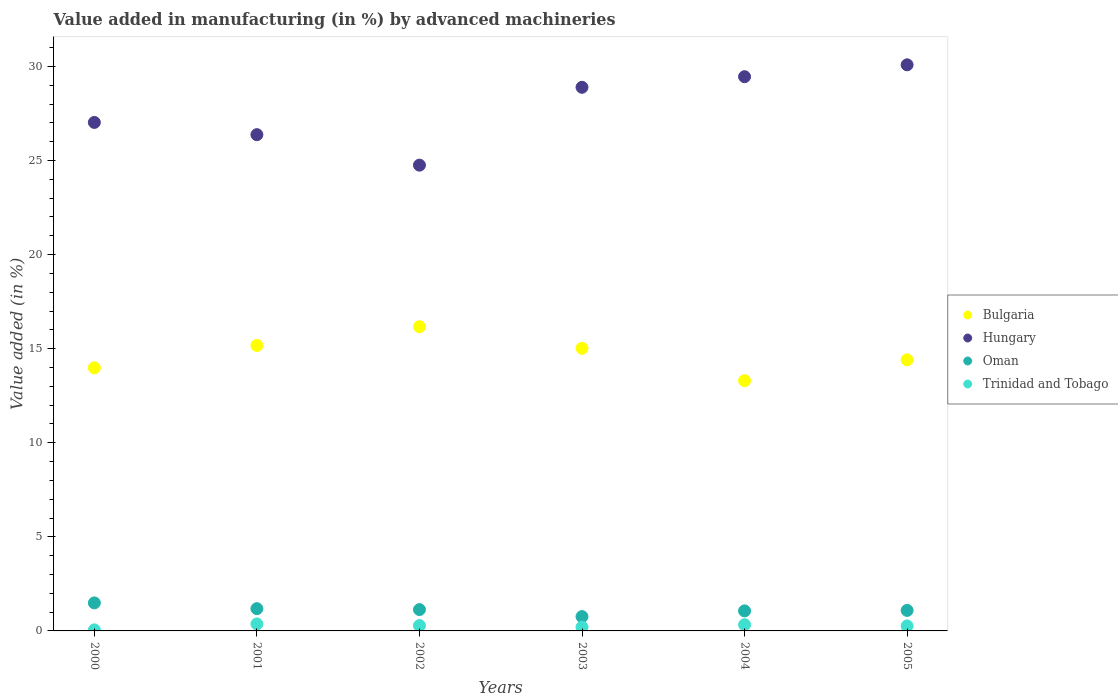Is the number of dotlines equal to the number of legend labels?
Offer a very short reply. Yes. What is the percentage of value added in manufacturing by advanced machineries in Hungary in 2002?
Keep it short and to the point. 24.76. Across all years, what is the maximum percentage of value added in manufacturing by advanced machineries in Hungary?
Offer a terse response. 30.09. Across all years, what is the minimum percentage of value added in manufacturing by advanced machineries in Bulgaria?
Offer a terse response. 13.3. In which year was the percentage of value added in manufacturing by advanced machineries in Bulgaria maximum?
Give a very brief answer. 2002. What is the total percentage of value added in manufacturing by advanced machineries in Bulgaria in the graph?
Keep it short and to the point. 88.06. What is the difference between the percentage of value added in manufacturing by advanced machineries in Oman in 2000 and that in 2005?
Make the answer very short. 0.4. What is the difference between the percentage of value added in manufacturing by advanced machineries in Bulgaria in 2003 and the percentage of value added in manufacturing by advanced machineries in Trinidad and Tobago in 2005?
Give a very brief answer. 14.76. What is the average percentage of value added in manufacturing by advanced machineries in Oman per year?
Your response must be concise. 1.12. In the year 2003, what is the difference between the percentage of value added in manufacturing by advanced machineries in Hungary and percentage of value added in manufacturing by advanced machineries in Oman?
Give a very brief answer. 28.13. In how many years, is the percentage of value added in manufacturing by advanced machineries in Hungary greater than 20 %?
Offer a terse response. 6. What is the ratio of the percentage of value added in manufacturing by advanced machineries in Oman in 2001 to that in 2003?
Give a very brief answer. 1.55. What is the difference between the highest and the second highest percentage of value added in manufacturing by advanced machineries in Hungary?
Your response must be concise. 0.63. What is the difference between the highest and the lowest percentage of value added in manufacturing by advanced machineries in Trinidad and Tobago?
Your response must be concise. 0.31. In how many years, is the percentage of value added in manufacturing by advanced machineries in Oman greater than the average percentage of value added in manufacturing by advanced machineries in Oman taken over all years?
Offer a very short reply. 3. Is the sum of the percentage of value added in manufacturing by advanced machineries in Hungary in 2000 and 2003 greater than the maximum percentage of value added in manufacturing by advanced machineries in Bulgaria across all years?
Offer a very short reply. Yes. Is it the case that in every year, the sum of the percentage of value added in manufacturing by advanced machineries in Bulgaria and percentage of value added in manufacturing by advanced machineries in Oman  is greater than the sum of percentage of value added in manufacturing by advanced machineries in Hungary and percentage of value added in manufacturing by advanced machineries in Trinidad and Tobago?
Make the answer very short. Yes. Does the percentage of value added in manufacturing by advanced machineries in Trinidad and Tobago monotonically increase over the years?
Ensure brevity in your answer.  No. How many dotlines are there?
Your response must be concise. 4. How many years are there in the graph?
Your answer should be very brief. 6. Are the values on the major ticks of Y-axis written in scientific E-notation?
Your response must be concise. No. Does the graph contain any zero values?
Provide a short and direct response. No. Where does the legend appear in the graph?
Keep it short and to the point. Center right. How many legend labels are there?
Provide a short and direct response. 4. How are the legend labels stacked?
Offer a terse response. Vertical. What is the title of the graph?
Provide a short and direct response. Value added in manufacturing (in %) by advanced machineries. Does "Qatar" appear as one of the legend labels in the graph?
Offer a very short reply. No. What is the label or title of the Y-axis?
Provide a succinct answer. Value added (in %). What is the Value added (in %) in Bulgaria in 2000?
Keep it short and to the point. 13.99. What is the Value added (in %) in Hungary in 2000?
Your answer should be compact. 27.03. What is the Value added (in %) of Oman in 2000?
Ensure brevity in your answer.  1.49. What is the Value added (in %) in Trinidad and Tobago in 2000?
Your response must be concise. 0.06. What is the Value added (in %) in Bulgaria in 2001?
Offer a terse response. 15.17. What is the Value added (in %) of Hungary in 2001?
Your response must be concise. 26.38. What is the Value added (in %) in Oman in 2001?
Your response must be concise. 1.18. What is the Value added (in %) in Trinidad and Tobago in 2001?
Ensure brevity in your answer.  0.37. What is the Value added (in %) in Bulgaria in 2002?
Offer a terse response. 16.17. What is the Value added (in %) of Hungary in 2002?
Your response must be concise. 24.76. What is the Value added (in %) of Oman in 2002?
Provide a short and direct response. 1.13. What is the Value added (in %) of Trinidad and Tobago in 2002?
Ensure brevity in your answer.  0.28. What is the Value added (in %) in Bulgaria in 2003?
Provide a succinct answer. 15.02. What is the Value added (in %) of Hungary in 2003?
Your answer should be very brief. 28.89. What is the Value added (in %) of Oman in 2003?
Make the answer very short. 0.76. What is the Value added (in %) in Trinidad and Tobago in 2003?
Provide a short and direct response. 0.2. What is the Value added (in %) in Bulgaria in 2004?
Make the answer very short. 13.3. What is the Value added (in %) in Hungary in 2004?
Make the answer very short. 29.46. What is the Value added (in %) in Oman in 2004?
Give a very brief answer. 1.07. What is the Value added (in %) in Trinidad and Tobago in 2004?
Make the answer very short. 0.33. What is the Value added (in %) in Bulgaria in 2005?
Ensure brevity in your answer.  14.41. What is the Value added (in %) in Hungary in 2005?
Offer a very short reply. 30.09. What is the Value added (in %) of Oman in 2005?
Offer a terse response. 1.09. What is the Value added (in %) of Trinidad and Tobago in 2005?
Offer a terse response. 0.27. Across all years, what is the maximum Value added (in %) of Bulgaria?
Make the answer very short. 16.17. Across all years, what is the maximum Value added (in %) of Hungary?
Provide a succinct answer. 30.09. Across all years, what is the maximum Value added (in %) of Oman?
Offer a very short reply. 1.49. Across all years, what is the maximum Value added (in %) of Trinidad and Tobago?
Your answer should be compact. 0.37. Across all years, what is the minimum Value added (in %) in Bulgaria?
Make the answer very short. 13.3. Across all years, what is the minimum Value added (in %) in Hungary?
Your answer should be compact. 24.76. Across all years, what is the minimum Value added (in %) in Oman?
Offer a very short reply. 0.76. Across all years, what is the minimum Value added (in %) in Trinidad and Tobago?
Give a very brief answer. 0.06. What is the total Value added (in %) of Bulgaria in the graph?
Make the answer very short. 88.06. What is the total Value added (in %) of Hungary in the graph?
Provide a succinct answer. 166.6. What is the total Value added (in %) in Oman in the graph?
Give a very brief answer. 6.72. What is the total Value added (in %) of Trinidad and Tobago in the graph?
Your answer should be compact. 1.51. What is the difference between the Value added (in %) in Bulgaria in 2000 and that in 2001?
Your answer should be compact. -1.19. What is the difference between the Value added (in %) in Hungary in 2000 and that in 2001?
Provide a short and direct response. 0.65. What is the difference between the Value added (in %) of Oman in 2000 and that in 2001?
Offer a very short reply. 0.31. What is the difference between the Value added (in %) in Trinidad and Tobago in 2000 and that in 2001?
Offer a very short reply. -0.31. What is the difference between the Value added (in %) of Bulgaria in 2000 and that in 2002?
Make the answer very short. -2.18. What is the difference between the Value added (in %) of Hungary in 2000 and that in 2002?
Give a very brief answer. 2.27. What is the difference between the Value added (in %) in Oman in 2000 and that in 2002?
Give a very brief answer. 0.36. What is the difference between the Value added (in %) in Trinidad and Tobago in 2000 and that in 2002?
Give a very brief answer. -0.23. What is the difference between the Value added (in %) of Bulgaria in 2000 and that in 2003?
Keep it short and to the point. -1.04. What is the difference between the Value added (in %) in Hungary in 2000 and that in 2003?
Offer a very short reply. -1.87. What is the difference between the Value added (in %) in Oman in 2000 and that in 2003?
Make the answer very short. 0.73. What is the difference between the Value added (in %) of Trinidad and Tobago in 2000 and that in 2003?
Your answer should be very brief. -0.15. What is the difference between the Value added (in %) of Bulgaria in 2000 and that in 2004?
Make the answer very short. 0.68. What is the difference between the Value added (in %) of Hungary in 2000 and that in 2004?
Your answer should be compact. -2.43. What is the difference between the Value added (in %) of Oman in 2000 and that in 2004?
Keep it short and to the point. 0.42. What is the difference between the Value added (in %) in Trinidad and Tobago in 2000 and that in 2004?
Give a very brief answer. -0.27. What is the difference between the Value added (in %) of Bulgaria in 2000 and that in 2005?
Provide a short and direct response. -0.42. What is the difference between the Value added (in %) of Hungary in 2000 and that in 2005?
Provide a succinct answer. -3.06. What is the difference between the Value added (in %) in Oman in 2000 and that in 2005?
Keep it short and to the point. 0.4. What is the difference between the Value added (in %) in Trinidad and Tobago in 2000 and that in 2005?
Ensure brevity in your answer.  -0.21. What is the difference between the Value added (in %) in Bulgaria in 2001 and that in 2002?
Keep it short and to the point. -1. What is the difference between the Value added (in %) in Hungary in 2001 and that in 2002?
Keep it short and to the point. 1.62. What is the difference between the Value added (in %) in Trinidad and Tobago in 2001 and that in 2002?
Your answer should be compact. 0.09. What is the difference between the Value added (in %) in Bulgaria in 2001 and that in 2003?
Ensure brevity in your answer.  0.15. What is the difference between the Value added (in %) in Hungary in 2001 and that in 2003?
Offer a terse response. -2.52. What is the difference between the Value added (in %) of Oman in 2001 and that in 2003?
Provide a short and direct response. 0.42. What is the difference between the Value added (in %) of Trinidad and Tobago in 2001 and that in 2003?
Offer a terse response. 0.17. What is the difference between the Value added (in %) in Bulgaria in 2001 and that in 2004?
Ensure brevity in your answer.  1.87. What is the difference between the Value added (in %) of Hungary in 2001 and that in 2004?
Offer a very short reply. -3.08. What is the difference between the Value added (in %) of Oman in 2001 and that in 2004?
Ensure brevity in your answer.  0.12. What is the difference between the Value added (in %) of Trinidad and Tobago in 2001 and that in 2004?
Give a very brief answer. 0.04. What is the difference between the Value added (in %) of Bulgaria in 2001 and that in 2005?
Give a very brief answer. 0.76. What is the difference between the Value added (in %) in Hungary in 2001 and that in 2005?
Provide a succinct answer. -3.71. What is the difference between the Value added (in %) of Oman in 2001 and that in 2005?
Your answer should be compact. 0.09. What is the difference between the Value added (in %) of Trinidad and Tobago in 2001 and that in 2005?
Provide a short and direct response. 0.1. What is the difference between the Value added (in %) in Bulgaria in 2002 and that in 2003?
Your response must be concise. 1.15. What is the difference between the Value added (in %) in Hungary in 2002 and that in 2003?
Your answer should be compact. -4.14. What is the difference between the Value added (in %) in Oman in 2002 and that in 2003?
Offer a very short reply. 0.37. What is the difference between the Value added (in %) in Trinidad and Tobago in 2002 and that in 2003?
Your answer should be very brief. 0.08. What is the difference between the Value added (in %) in Bulgaria in 2002 and that in 2004?
Offer a very short reply. 2.87. What is the difference between the Value added (in %) in Hungary in 2002 and that in 2004?
Provide a short and direct response. -4.7. What is the difference between the Value added (in %) of Oman in 2002 and that in 2004?
Your answer should be compact. 0.07. What is the difference between the Value added (in %) of Trinidad and Tobago in 2002 and that in 2004?
Your answer should be compact. -0.05. What is the difference between the Value added (in %) of Bulgaria in 2002 and that in 2005?
Provide a short and direct response. 1.76. What is the difference between the Value added (in %) of Hungary in 2002 and that in 2005?
Make the answer very short. -5.33. What is the difference between the Value added (in %) in Oman in 2002 and that in 2005?
Offer a very short reply. 0.04. What is the difference between the Value added (in %) of Trinidad and Tobago in 2002 and that in 2005?
Provide a short and direct response. 0.02. What is the difference between the Value added (in %) in Bulgaria in 2003 and that in 2004?
Offer a terse response. 1.72. What is the difference between the Value added (in %) of Hungary in 2003 and that in 2004?
Ensure brevity in your answer.  -0.56. What is the difference between the Value added (in %) in Oman in 2003 and that in 2004?
Ensure brevity in your answer.  -0.3. What is the difference between the Value added (in %) in Trinidad and Tobago in 2003 and that in 2004?
Give a very brief answer. -0.13. What is the difference between the Value added (in %) of Bulgaria in 2003 and that in 2005?
Offer a terse response. 0.61. What is the difference between the Value added (in %) in Hungary in 2003 and that in 2005?
Your response must be concise. -1.19. What is the difference between the Value added (in %) in Oman in 2003 and that in 2005?
Your response must be concise. -0.33. What is the difference between the Value added (in %) of Trinidad and Tobago in 2003 and that in 2005?
Offer a terse response. -0.06. What is the difference between the Value added (in %) of Bulgaria in 2004 and that in 2005?
Offer a very short reply. -1.11. What is the difference between the Value added (in %) in Hungary in 2004 and that in 2005?
Your response must be concise. -0.63. What is the difference between the Value added (in %) in Oman in 2004 and that in 2005?
Provide a short and direct response. -0.03. What is the difference between the Value added (in %) in Trinidad and Tobago in 2004 and that in 2005?
Make the answer very short. 0.06. What is the difference between the Value added (in %) of Bulgaria in 2000 and the Value added (in %) of Hungary in 2001?
Provide a short and direct response. -12.39. What is the difference between the Value added (in %) in Bulgaria in 2000 and the Value added (in %) in Oman in 2001?
Your response must be concise. 12.8. What is the difference between the Value added (in %) of Bulgaria in 2000 and the Value added (in %) of Trinidad and Tobago in 2001?
Your answer should be very brief. 13.61. What is the difference between the Value added (in %) in Hungary in 2000 and the Value added (in %) in Oman in 2001?
Your answer should be compact. 25.84. What is the difference between the Value added (in %) in Hungary in 2000 and the Value added (in %) in Trinidad and Tobago in 2001?
Offer a very short reply. 26.66. What is the difference between the Value added (in %) of Oman in 2000 and the Value added (in %) of Trinidad and Tobago in 2001?
Provide a succinct answer. 1.12. What is the difference between the Value added (in %) in Bulgaria in 2000 and the Value added (in %) in Hungary in 2002?
Keep it short and to the point. -10.77. What is the difference between the Value added (in %) of Bulgaria in 2000 and the Value added (in %) of Oman in 2002?
Give a very brief answer. 12.85. What is the difference between the Value added (in %) in Bulgaria in 2000 and the Value added (in %) in Trinidad and Tobago in 2002?
Keep it short and to the point. 13.7. What is the difference between the Value added (in %) of Hungary in 2000 and the Value added (in %) of Oman in 2002?
Provide a short and direct response. 25.89. What is the difference between the Value added (in %) in Hungary in 2000 and the Value added (in %) in Trinidad and Tobago in 2002?
Offer a very short reply. 26.74. What is the difference between the Value added (in %) of Oman in 2000 and the Value added (in %) of Trinidad and Tobago in 2002?
Your answer should be compact. 1.21. What is the difference between the Value added (in %) of Bulgaria in 2000 and the Value added (in %) of Hungary in 2003?
Make the answer very short. -14.91. What is the difference between the Value added (in %) of Bulgaria in 2000 and the Value added (in %) of Oman in 2003?
Your response must be concise. 13.22. What is the difference between the Value added (in %) of Bulgaria in 2000 and the Value added (in %) of Trinidad and Tobago in 2003?
Ensure brevity in your answer.  13.78. What is the difference between the Value added (in %) of Hungary in 2000 and the Value added (in %) of Oman in 2003?
Make the answer very short. 26.26. What is the difference between the Value added (in %) of Hungary in 2000 and the Value added (in %) of Trinidad and Tobago in 2003?
Your answer should be compact. 26.82. What is the difference between the Value added (in %) in Oman in 2000 and the Value added (in %) in Trinidad and Tobago in 2003?
Keep it short and to the point. 1.29. What is the difference between the Value added (in %) of Bulgaria in 2000 and the Value added (in %) of Hungary in 2004?
Keep it short and to the point. -15.47. What is the difference between the Value added (in %) of Bulgaria in 2000 and the Value added (in %) of Oman in 2004?
Keep it short and to the point. 12.92. What is the difference between the Value added (in %) in Bulgaria in 2000 and the Value added (in %) in Trinidad and Tobago in 2004?
Your response must be concise. 13.65. What is the difference between the Value added (in %) of Hungary in 2000 and the Value added (in %) of Oman in 2004?
Make the answer very short. 25.96. What is the difference between the Value added (in %) in Hungary in 2000 and the Value added (in %) in Trinidad and Tobago in 2004?
Provide a succinct answer. 26.7. What is the difference between the Value added (in %) of Oman in 2000 and the Value added (in %) of Trinidad and Tobago in 2004?
Your answer should be very brief. 1.16. What is the difference between the Value added (in %) in Bulgaria in 2000 and the Value added (in %) in Hungary in 2005?
Offer a very short reply. -16.1. What is the difference between the Value added (in %) in Bulgaria in 2000 and the Value added (in %) in Oman in 2005?
Provide a succinct answer. 12.89. What is the difference between the Value added (in %) in Bulgaria in 2000 and the Value added (in %) in Trinidad and Tobago in 2005?
Provide a short and direct response. 13.72. What is the difference between the Value added (in %) of Hungary in 2000 and the Value added (in %) of Oman in 2005?
Make the answer very short. 25.94. What is the difference between the Value added (in %) of Hungary in 2000 and the Value added (in %) of Trinidad and Tobago in 2005?
Give a very brief answer. 26.76. What is the difference between the Value added (in %) in Oman in 2000 and the Value added (in %) in Trinidad and Tobago in 2005?
Your answer should be compact. 1.22. What is the difference between the Value added (in %) of Bulgaria in 2001 and the Value added (in %) of Hungary in 2002?
Your response must be concise. -9.58. What is the difference between the Value added (in %) of Bulgaria in 2001 and the Value added (in %) of Oman in 2002?
Offer a very short reply. 14.04. What is the difference between the Value added (in %) of Bulgaria in 2001 and the Value added (in %) of Trinidad and Tobago in 2002?
Your answer should be compact. 14.89. What is the difference between the Value added (in %) in Hungary in 2001 and the Value added (in %) in Oman in 2002?
Your answer should be very brief. 25.24. What is the difference between the Value added (in %) of Hungary in 2001 and the Value added (in %) of Trinidad and Tobago in 2002?
Offer a terse response. 26.09. What is the difference between the Value added (in %) in Oman in 2001 and the Value added (in %) in Trinidad and Tobago in 2002?
Provide a short and direct response. 0.9. What is the difference between the Value added (in %) in Bulgaria in 2001 and the Value added (in %) in Hungary in 2003?
Keep it short and to the point. -13.72. What is the difference between the Value added (in %) in Bulgaria in 2001 and the Value added (in %) in Oman in 2003?
Ensure brevity in your answer.  14.41. What is the difference between the Value added (in %) in Bulgaria in 2001 and the Value added (in %) in Trinidad and Tobago in 2003?
Your response must be concise. 14.97. What is the difference between the Value added (in %) of Hungary in 2001 and the Value added (in %) of Oman in 2003?
Offer a very short reply. 25.61. What is the difference between the Value added (in %) of Hungary in 2001 and the Value added (in %) of Trinidad and Tobago in 2003?
Give a very brief answer. 26.17. What is the difference between the Value added (in %) in Oman in 2001 and the Value added (in %) in Trinidad and Tobago in 2003?
Provide a short and direct response. 0.98. What is the difference between the Value added (in %) of Bulgaria in 2001 and the Value added (in %) of Hungary in 2004?
Provide a succinct answer. -14.28. What is the difference between the Value added (in %) in Bulgaria in 2001 and the Value added (in %) in Oman in 2004?
Your response must be concise. 14.11. What is the difference between the Value added (in %) in Bulgaria in 2001 and the Value added (in %) in Trinidad and Tobago in 2004?
Keep it short and to the point. 14.84. What is the difference between the Value added (in %) of Hungary in 2001 and the Value added (in %) of Oman in 2004?
Provide a succinct answer. 25.31. What is the difference between the Value added (in %) in Hungary in 2001 and the Value added (in %) in Trinidad and Tobago in 2004?
Your response must be concise. 26.05. What is the difference between the Value added (in %) in Oman in 2001 and the Value added (in %) in Trinidad and Tobago in 2004?
Provide a short and direct response. 0.85. What is the difference between the Value added (in %) of Bulgaria in 2001 and the Value added (in %) of Hungary in 2005?
Provide a short and direct response. -14.92. What is the difference between the Value added (in %) in Bulgaria in 2001 and the Value added (in %) in Oman in 2005?
Offer a terse response. 14.08. What is the difference between the Value added (in %) of Bulgaria in 2001 and the Value added (in %) of Trinidad and Tobago in 2005?
Keep it short and to the point. 14.91. What is the difference between the Value added (in %) of Hungary in 2001 and the Value added (in %) of Oman in 2005?
Make the answer very short. 25.29. What is the difference between the Value added (in %) of Hungary in 2001 and the Value added (in %) of Trinidad and Tobago in 2005?
Make the answer very short. 26.11. What is the difference between the Value added (in %) in Oman in 2001 and the Value added (in %) in Trinidad and Tobago in 2005?
Give a very brief answer. 0.92. What is the difference between the Value added (in %) of Bulgaria in 2002 and the Value added (in %) of Hungary in 2003?
Give a very brief answer. -12.73. What is the difference between the Value added (in %) in Bulgaria in 2002 and the Value added (in %) in Oman in 2003?
Keep it short and to the point. 15.41. What is the difference between the Value added (in %) of Bulgaria in 2002 and the Value added (in %) of Trinidad and Tobago in 2003?
Your response must be concise. 15.97. What is the difference between the Value added (in %) in Hungary in 2002 and the Value added (in %) in Oman in 2003?
Your answer should be very brief. 23.99. What is the difference between the Value added (in %) in Hungary in 2002 and the Value added (in %) in Trinidad and Tobago in 2003?
Ensure brevity in your answer.  24.55. What is the difference between the Value added (in %) of Oman in 2002 and the Value added (in %) of Trinidad and Tobago in 2003?
Offer a very short reply. 0.93. What is the difference between the Value added (in %) of Bulgaria in 2002 and the Value added (in %) of Hungary in 2004?
Make the answer very short. -13.29. What is the difference between the Value added (in %) of Bulgaria in 2002 and the Value added (in %) of Oman in 2004?
Provide a short and direct response. 15.1. What is the difference between the Value added (in %) in Bulgaria in 2002 and the Value added (in %) in Trinidad and Tobago in 2004?
Give a very brief answer. 15.84. What is the difference between the Value added (in %) of Hungary in 2002 and the Value added (in %) of Oman in 2004?
Your answer should be compact. 23.69. What is the difference between the Value added (in %) in Hungary in 2002 and the Value added (in %) in Trinidad and Tobago in 2004?
Your answer should be very brief. 24.43. What is the difference between the Value added (in %) in Oman in 2002 and the Value added (in %) in Trinidad and Tobago in 2004?
Provide a succinct answer. 0.8. What is the difference between the Value added (in %) in Bulgaria in 2002 and the Value added (in %) in Hungary in 2005?
Provide a succinct answer. -13.92. What is the difference between the Value added (in %) of Bulgaria in 2002 and the Value added (in %) of Oman in 2005?
Keep it short and to the point. 15.08. What is the difference between the Value added (in %) of Bulgaria in 2002 and the Value added (in %) of Trinidad and Tobago in 2005?
Your answer should be very brief. 15.9. What is the difference between the Value added (in %) of Hungary in 2002 and the Value added (in %) of Oman in 2005?
Your answer should be very brief. 23.66. What is the difference between the Value added (in %) in Hungary in 2002 and the Value added (in %) in Trinidad and Tobago in 2005?
Offer a terse response. 24.49. What is the difference between the Value added (in %) in Oman in 2002 and the Value added (in %) in Trinidad and Tobago in 2005?
Ensure brevity in your answer.  0.87. What is the difference between the Value added (in %) in Bulgaria in 2003 and the Value added (in %) in Hungary in 2004?
Provide a short and direct response. -14.44. What is the difference between the Value added (in %) in Bulgaria in 2003 and the Value added (in %) in Oman in 2004?
Your answer should be compact. 13.96. What is the difference between the Value added (in %) of Bulgaria in 2003 and the Value added (in %) of Trinidad and Tobago in 2004?
Your answer should be compact. 14.69. What is the difference between the Value added (in %) in Hungary in 2003 and the Value added (in %) in Oman in 2004?
Ensure brevity in your answer.  27.83. What is the difference between the Value added (in %) in Hungary in 2003 and the Value added (in %) in Trinidad and Tobago in 2004?
Your answer should be compact. 28.56. What is the difference between the Value added (in %) in Oman in 2003 and the Value added (in %) in Trinidad and Tobago in 2004?
Offer a terse response. 0.43. What is the difference between the Value added (in %) in Bulgaria in 2003 and the Value added (in %) in Hungary in 2005?
Your response must be concise. -15.07. What is the difference between the Value added (in %) of Bulgaria in 2003 and the Value added (in %) of Oman in 2005?
Keep it short and to the point. 13.93. What is the difference between the Value added (in %) in Bulgaria in 2003 and the Value added (in %) in Trinidad and Tobago in 2005?
Ensure brevity in your answer.  14.76. What is the difference between the Value added (in %) in Hungary in 2003 and the Value added (in %) in Oman in 2005?
Make the answer very short. 27.8. What is the difference between the Value added (in %) in Hungary in 2003 and the Value added (in %) in Trinidad and Tobago in 2005?
Provide a succinct answer. 28.63. What is the difference between the Value added (in %) of Oman in 2003 and the Value added (in %) of Trinidad and Tobago in 2005?
Your answer should be very brief. 0.5. What is the difference between the Value added (in %) in Bulgaria in 2004 and the Value added (in %) in Hungary in 2005?
Offer a terse response. -16.79. What is the difference between the Value added (in %) in Bulgaria in 2004 and the Value added (in %) in Oman in 2005?
Your answer should be very brief. 12.21. What is the difference between the Value added (in %) in Bulgaria in 2004 and the Value added (in %) in Trinidad and Tobago in 2005?
Give a very brief answer. 13.04. What is the difference between the Value added (in %) in Hungary in 2004 and the Value added (in %) in Oman in 2005?
Ensure brevity in your answer.  28.37. What is the difference between the Value added (in %) of Hungary in 2004 and the Value added (in %) of Trinidad and Tobago in 2005?
Provide a succinct answer. 29.19. What is the difference between the Value added (in %) of Oman in 2004 and the Value added (in %) of Trinidad and Tobago in 2005?
Ensure brevity in your answer.  0.8. What is the average Value added (in %) of Bulgaria per year?
Make the answer very short. 14.68. What is the average Value added (in %) in Hungary per year?
Your answer should be very brief. 27.77. What is the average Value added (in %) of Oman per year?
Ensure brevity in your answer.  1.12. What is the average Value added (in %) of Trinidad and Tobago per year?
Offer a terse response. 0.25. In the year 2000, what is the difference between the Value added (in %) of Bulgaria and Value added (in %) of Hungary?
Make the answer very short. -13.04. In the year 2000, what is the difference between the Value added (in %) of Bulgaria and Value added (in %) of Oman?
Your response must be concise. 12.5. In the year 2000, what is the difference between the Value added (in %) in Bulgaria and Value added (in %) in Trinidad and Tobago?
Offer a very short reply. 13.93. In the year 2000, what is the difference between the Value added (in %) of Hungary and Value added (in %) of Oman?
Keep it short and to the point. 25.54. In the year 2000, what is the difference between the Value added (in %) in Hungary and Value added (in %) in Trinidad and Tobago?
Your answer should be compact. 26.97. In the year 2000, what is the difference between the Value added (in %) of Oman and Value added (in %) of Trinidad and Tobago?
Ensure brevity in your answer.  1.43. In the year 2001, what is the difference between the Value added (in %) of Bulgaria and Value added (in %) of Hungary?
Provide a succinct answer. -11.2. In the year 2001, what is the difference between the Value added (in %) of Bulgaria and Value added (in %) of Oman?
Offer a very short reply. 13.99. In the year 2001, what is the difference between the Value added (in %) of Bulgaria and Value added (in %) of Trinidad and Tobago?
Your answer should be very brief. 14.8. In the year 2001, what is the difference between the Value added (in %) of Hungary and Value added (in %) of Oman?
Your response must be concise. 25.19. In the year 2001, what is the difference between the Value added (in %) in Hungary and Value added (in %) in Trinidad and Tobago?
Your response must be concise. 26.01. In the year 2001, what is the difference between the Value added (in %) in Oman and Value added (in %) in Trinidad and Tobago?
Offer a very short reply. 0.81. In the year 2002, what is the difference between the Value added (in %) in Bulgaria and Value added (in %) in Hungary?
Your answer should be compact. -8.59. In the year 2002, what is the difference between the Value added (in %) of Bulgaria and Value added (in %) of Oman?
Keep it short and to the point. 15.04. In the year 2002, what is the difference between the Value added (in %) in Bulgaria and Value added (in %) in Trinidad and Tobago?
Ensure brevity in your answer.  15.89. In the year 2002, what is the difference between the Value added (in %) in Hungary and Value added (in %) in Oman?
Keep it short and to the point. 23.62. In the year 2002, what is the difference between the Value added (in %) of Hungary and Value added (in %) of Trinidad and Tobago?
Give a very brief answer. 24.47. In the year 2002, what is the difference between the Value added (in %) in Oman and Value added (in %) in Trinidad and Tobago?
Keep it short and to the point. 0.85. In the year 2003, what is the difference between the Value added (in %) in Bulgaria and Value added (in %) in Hungary?
Offer a very short reply. -13.87. In the year 2003, what is the difference between the Value added (in %) in Bulgaria and Value added (in %) in Oman?
Your response must be concise. 14.26. In the year 2003, what is the difference between the Value added (in %) of Bulgaria and Value added (in %) of Trinidad and Tobago?
Your answer should be compact. 14.82. In the year 2003, what is the difference between the Value added (in %) of Hungary and Value added (in %) of Oman?
Your answer should be very brief. 28.13. In the year 2003, what is the difference between the Value added (in %) in Hungary and Value added (in %) in Trinidad and Tobago?
Offer a terse response. 28.69. In the year 2003, what is the difference between the Value added (in %) in Oman and Value added (in %) in Trinidad and Tobago?
Provide a short and direct response. 0.56. In the year 2004, what is the difference between the Value added (in %) in Bulgaria and Value added (in %) in Hungary?
Provide a short and direct response. -16.16. In the year 2004, what is the difference between the Value added (in %) in Bulgaria and Value added (in %) in Oman?
Keep it short and to the point. 12.24. In the year 2004, what is the difference between the Value added (in %) of Bulgaria and Value added (in %) of Trinidad and Tobago?
Offer a very short reply. 12.97. In the year 2004, what is the difference between the Value added (in %) in Hungary and Value added (in %) in Oman?
Make the answer very short. 28.39. In the year 2004, what is the difference between the Value added (in %) of Hungary and Value added (in %) of Trinidad and Tobago?
Make the answer very short. 29.13. In the year 2004, what is the difference between the Value added (in %) of Oman and Value added (in %) of Trinidad and Tobago?
Make the answer very short. 0.73. In the year 2005, what is the difference between the Value added (in %) of Bulgaria and Value added (in %) of Hungary?
Keep it short and to the point. -15.68. In the year 2005, what is the difference between the Value added (in %) of Bulgaria and Value added (in %) of Oman?
Provide a succinct answer. 13.32. In the year 2005, what is the difference between the Value added (in %) of Bulgaria and Value added (in %) of Trinidad and Tobago?
Your answer should be very brief. 14.14. In the year 2005, what is the difference between the Value added (in %) of Hungary and Value added (in %) of Oman?
Your answer should be compact. 29. In the year 2005, what is the difference between the Value added (in %) of Hungary and Value added (in %) of Trinidad and Tobago?
Offer a terse response. 29.82. In the year 2005, what is the difference between the Value added (in %) in Oman and Value added (in %) in Trinidad and Tobago?
Provide a succinct answer. 0.82. What is the ratio of the Value added (in %) of Bulgaria in 2000 to that in 2001?
Your answer should be very brief. 0.92. What is the ratio of the Value added (in %) in Hungary in 2000 to that in 2001?
Provide a short and direct response. 1.02. What is the ratio of the Value added (in %) in Oman in 2000 to that in 2001?
Your answer should be very brief. 1.26. What is the ratio of the Value added (in %) in Trinidad and Tobago in 2000 to that in 2001?
Your answer should be very brief. 0.15. What is the ratio of the Value added (in %) in Bulgaria in 2000 to that in 2002?
Give a very brief answer. 0.86. What is the ratio of the Value added (in %) in Hungary in 2000 to that in 2002?
Make the answer very short. 1.09. What is the ratio of the Value added (in %) in Oman in 2000 to that in 2002?
Provide a succinct answer. 1.31. What is the ratio of the Value added (in %) in Trinidad and Tobago in 2000 to that in 2002?
Offer a terse response. 0.2. What is the ratio of the Value added (in %) of Hungary in 2000 to that in 2003?
Your answer should be very brief. 0.94. What is the ratio of the Value added (in %) of Oman in 2000 to that in 2003?
Provide a succinct answer. 1.95. What is the ratio of the Value added (in %) of Trinidad and Tobago in 2000 to that in 2003?
Provide a succinct answer. 0.28. What is the ratio of the Value added (in %) in Bulgaria in 2000 to that in 2004?
Ensure brevity in your answer.  1.05. What is the ratio of the Value added (in %) of Hungary in 2000 to that in 2004?
Ensure brevity in your answer.  0.92. What is the ratio of the Value added (in %) of Oman in 2000 to that in 2004?
Your response must be concise. 1.4. What is the ratio of the Value added (in %) in Trinidad and Tobago in 2000 to that in 2004?
Provide a succinct answer. 0.17. What is the ratio of the Value added (in %) in Bulgaria in 2000 to that in 2005?
Ensure brevity in your answer.  0.97. What is the ratio of the Value added (in %) in Hungary in 2000 to that in 2005?
Ensure brevity in your answer.  0.9. What is the ratio of the Value added (in %) in Oman in 2000 to that in 2005?
Ensure brevity in your answer.  1.37. What is the ratio of the Value added (in %) in Trinidad and Tobago in 2000 to that in 2005?
Give a very brief answer. 0.21. What is the ratio of the Value added (in %) of Bulgaria in 2001 to that in 2002?
Keep it short and to the point. 0.94. What is the ratio of the Value added (in %) in Hungary in 2001 to that in 2002?
Provide a succinct answer. 1.07. What is the ratio of the Value added (in %) in Oman in 2001 to that in 2002?
Offer a very short reply. 1.04. What is the ratio of the Value added (in %) of Trinidad and Tobago in 2001 to that in 2002?
Offer a terse response. 1.31. What is the ratio of the Value added (in %) of Hungary in 2001 to that in 2003?
Your answer should be very brief. 0.91. What is the ratio of the Value added (in %) in Oman in 2001 to that in 2003?
Your response must be concise. 1.55. What is the ratio of the Value added (in %) in Trinidad and Tobago in 2001 to that in 2003?
Your response must be concise. 1.82. What is the ratio of the Value added (in %) in Bulgaria in 2001 to that in 2004?
Keep it short and to the point. 1.14. What is the ratio of the Value added (in %) of Hungary in 2001 to that in 2004?
Provide a succinct answer. 0.9. What is the ratio of the Value added (in %) of Oman in 2001 to that in 2004?
Your answer should be very brief. 1.11. What is the ratio of the Value added (in %) in Trinidad and Tobago in 2001 to that in 2004?
Give a very brief answer. 1.12. What is the ratio of the Value added (in %) in Bulgaria in 2001 to that in 2005?
Make the answer very short. 1.05. What is the ratio of the Value added (in %) of Hungary in 2001 to that in 2005?
Make the answer very short. 0.88. What is the ratio of the Value added (in %) of Oman in 2001 to that in 2005?
Provide a short and direct response. 1.08. What is the ratio of the Value added (in %) of Trinidad and Tobago in 2001 to that in 2005?
Give a very brief answer. 1.39. What is the ratio of the Value added (in %) in Bulgaria in 2002 to that in 2003?
Offer a very short reply. 1.08. What is the ratio of the Value added (in %) of Hungary in 2002 to that in 2003?
Your answer should be compact. 0.86. What is the ratio of the Value added (in %) in Oman in 2002 to that in 2003?
Provide a succinct answer. 1.49. What is the ratio of the Value added (in %) of Trinidad and Tobago in 2002 to that in 2003?
Give a very brief answer. 1.39. What is the ratio of the Value added (in %) of Bulgaria in 2002 to that in 2004?
Provide a short and direct response. 1.22. What is the ratio of the Value added (in %) of Hungary in 2002 to that in 2004?
Provide a succinct answer. 0.84. What is the ratio of the Value added (in %) in Oman in 2002 to that in 2004?
Offer a very short reply. 1.06. What is the ratio of the Value added (in %) of Trinidad and Tobago in 2002 to that in 2004?
Your answer should be compact. 0.86. What is the ratio of the Value added (in %) in Bulgaria in 2002 to that in 2005?
Your response must be concise. 1.12. What is the ratio of the Value added (in %) of Hungary in 2002 to that in 2005?
Offer a very short reply. 0.82. What is the ratio of the Value added (in %) in Oman in 2002 to that in 2005?
Offer a terse response. 1.04. What is the ratio of the Value added (in %) in Trinidad and Tobago in 2002 to that in 2005?
Provide a succinct answer. 1.07. What is the ratio of the Value added (in %) of Bulgaria in 2003 to that in 2004?
Make the answer very short. 1.13. What is the ratio of the Value added (in %) of Hungary in 2003 to that in 2004?
Make the answer very short. 0.98. What is the ratio of the Value added (in %) in Oman in 2003 to that in 2004?
Your response must be concise. 0.72. What is the ratio of the Value added (in %) of Trinidad and Tobago in 2003 to that in 2004?
Make the answer very short. 0.61. What is the ratio of the Value added (in %) in Bulgaria in 2003 to that in 2005?
Your response must be concise. 1.04. What is the ratio of the Value added (in %) in Hungary in 2003 to that in 2005?
Your answer should be compact. 0.96. What is the ratio of the Value added (in %) in Oman in 2003 to that in 2005?
Your answer should be compact. 0.7. What is the ratio of the Value added (in %) in Trinidad and Tobago in 2003 to that in 2005?
Your answer should be very brief. 0.76. What is the ratio of the Value added (in %) of Bulgaria in 2004 to that in 2005?
Make the answer very short. 0.92. What is the ratio of the Value added (in %) of Hungary in 2004 to that in 2005?
Your answer should be compact. 0.98. What is the ratio of the Value added (in %) in Oman in 2004 to that in 2005?
Offer a terse response. 0.98. What is the ratio of the Value added (in %) of Trinidad and Tobago in 2004 to that in 2005?
Make the answer very short. 1.24. What is the difference between the highest and the second highest Value added (in %) in Bulgaria?
Your answer should be very brief. 1. What is the difference between the highest and the second highest Value added (in %) of Hungary?
Offer a terse response. 0.63. What is the difference between the highest and the second highest Value added (in %) in Oman?
Offer a terse response. 0.31. What is the difference between the highest and the second highest Value added (in %) in Trinidad and Tobago?
Offer a terse response. 0.04. What is the difference between the highest and the lowest Value added (in %) in Bulgaria?
Give a very brief answer. 2.87. What is the difference between the highest and the lowest Value added (in %) in Hungary?
Provide a succinct answer. 5.33. What is the difference between the highest and the lowest Value added (in %) in Oman?
Ensure brevity in your answer.  0.73. What is the difference between the highest and the lowest Value added (in %) of Trinidad and Tobago?
Your response must be concise. 0.31. 